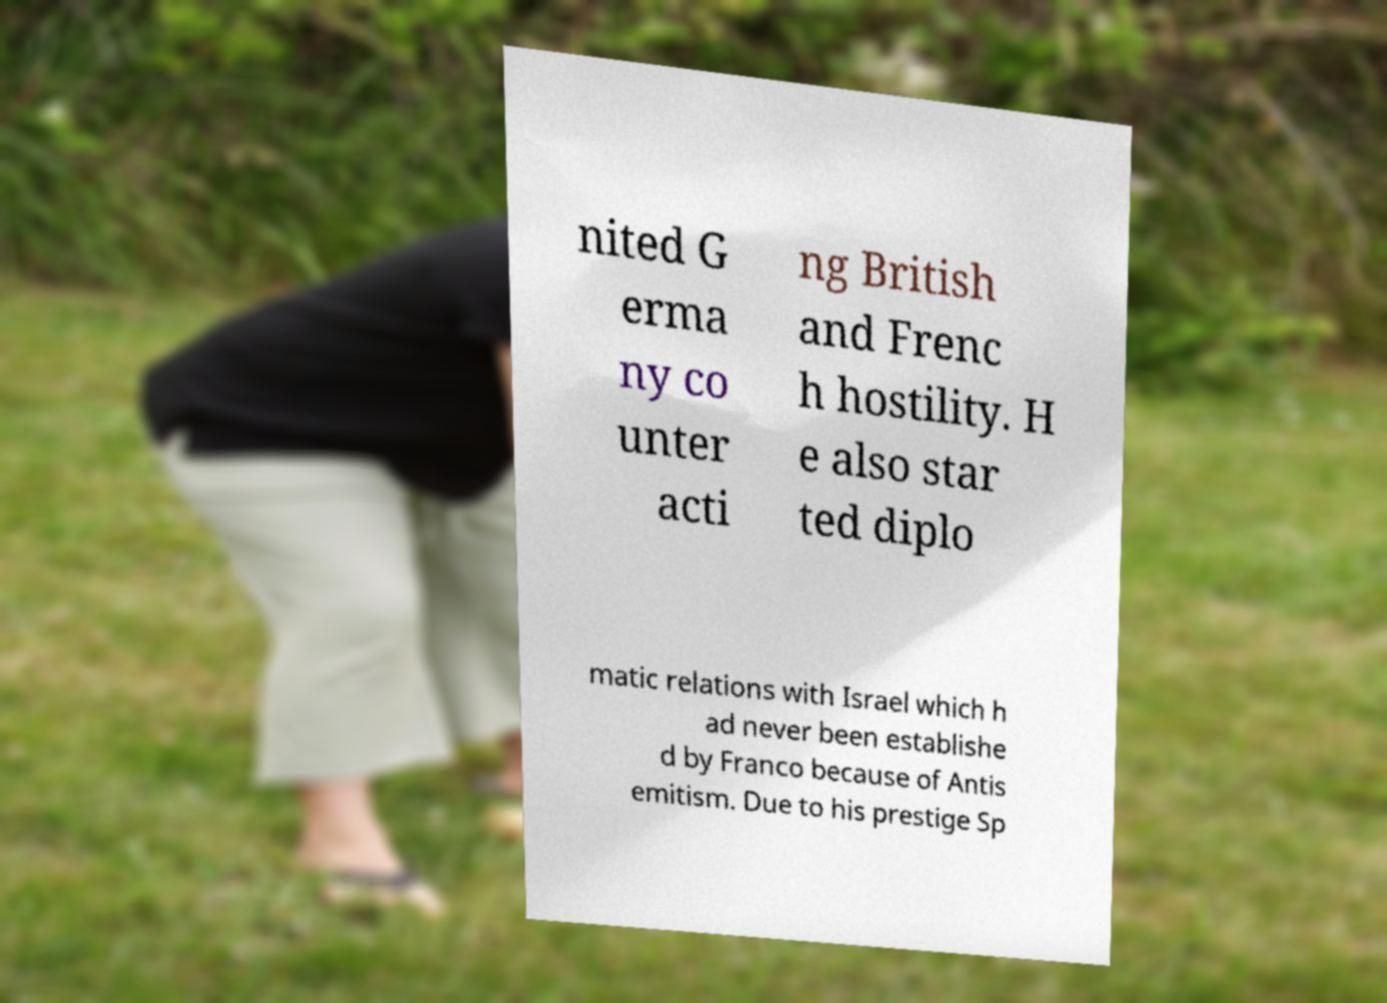Could you extract and type out the text from this image? nited G erma ny co unter acti ng British and Frenc h hostility. H e also star ted diplo matic relations with Israel which h ad never been establishe d by Franco because of Antis emitism. Due to his prestige Sp 